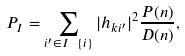<formula> <loc_0><loc_0><loc_500><loc_500>P _ { I } = \sum _ { i ^ { \prime } \in I \ \{ i \} } | h _ { k i ^ { \prime } } | ^ { 2 } \frac { P ( n ) } { D ( n ) } ,</formula> 